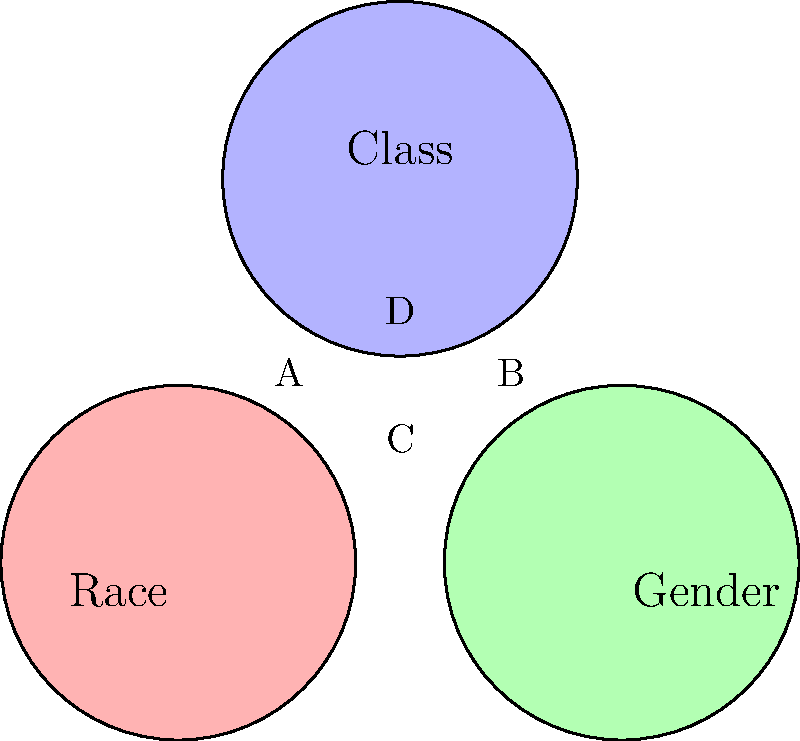In the Venn diagram above, which represents intersectionality through overlapping social identities, what does the central region D represent in terms of the social categories shown? To answer this question, we need to understand the concept of intersectionality and how it's visualized in the Venn diagram:

1. The diagram shows three overlapping circles representing different social categories: Race, Gender, and Class.

2. Each circle represents a distinct social identity or category:
   - The red circle (left) represents Race
   - The green circle (right) represents Gender
   - The blue circle (top) represents Class

3. Intersectionality is the concept that various social categories or identities intersect and interact, creating unique experiences of discrimination or privilege.

4. In the Venn diagram, the overlapping areas represent the intersections of these identities:
   - Area A: intersection of Race and Class
   - Area B: intersection of Gender and Class
   - Area C: intersection of Race and Gender

5. The central region D is where all three circles overlap, representing the intersection of all three social categories.

6. This central area D, therefore, represents individuals or groups who experience the combined effects of all three social categories simultaneously: Race, Gender, and Class.

Thus, region D represents the intersection of Race, Gender, and Class, embodying the core principle of intersectionality where multiple social identities converge to create a unique social position and experience.
Answer: The intersection of Race, Gender, and Class 